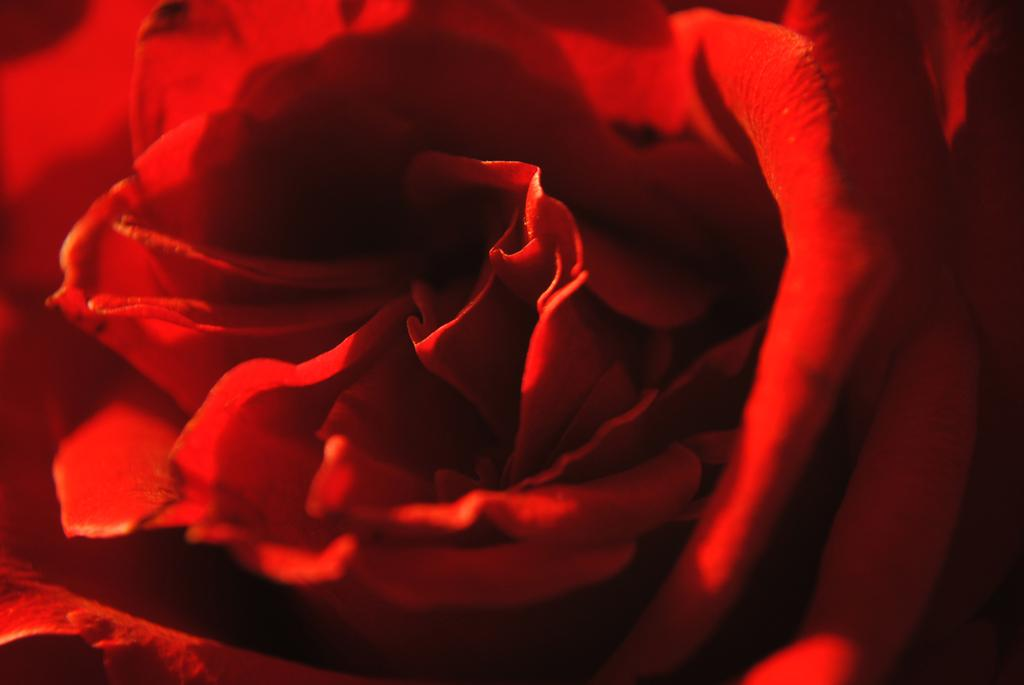What type of flower is present in the image? There is a red flower in the image. How many bricks are stacked on the stage with the cherries in the image? There is no mention of bricks, cherries, or a stage in the image. The image only contains a red flower. 